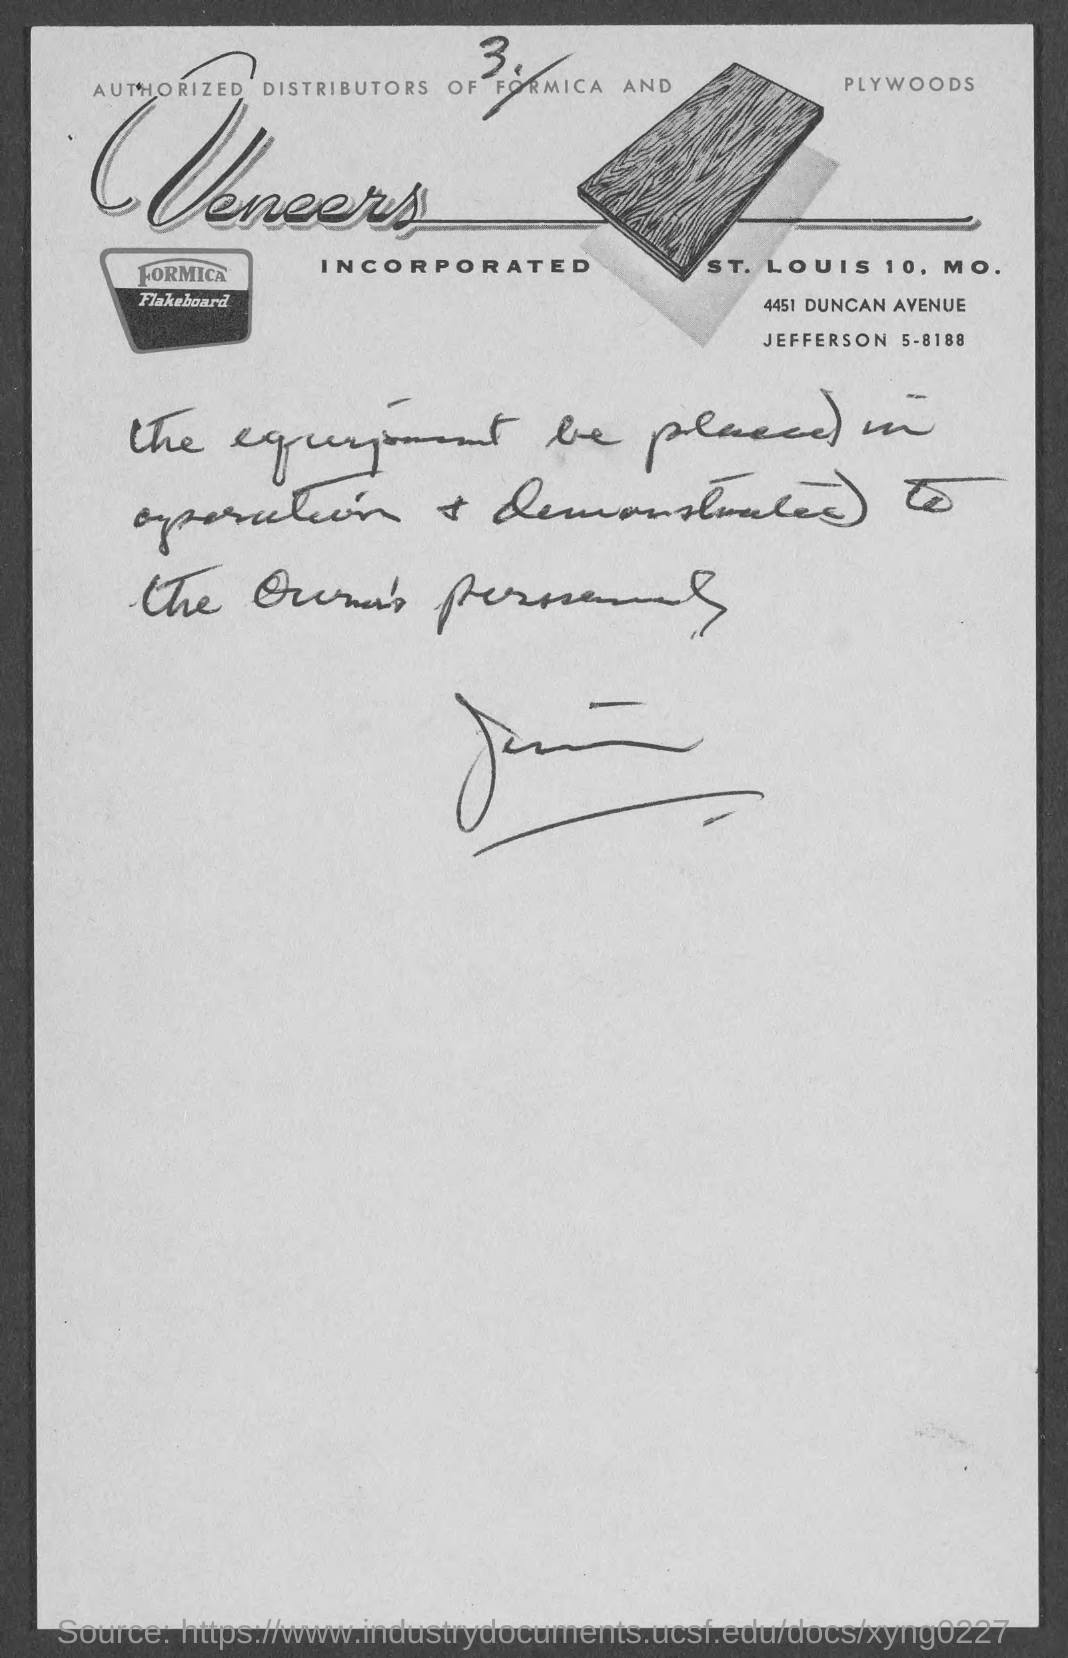Who are the Authorized Distributors of Formica and Plywoods
Offer a very short reply. Veneers Incorporated. 